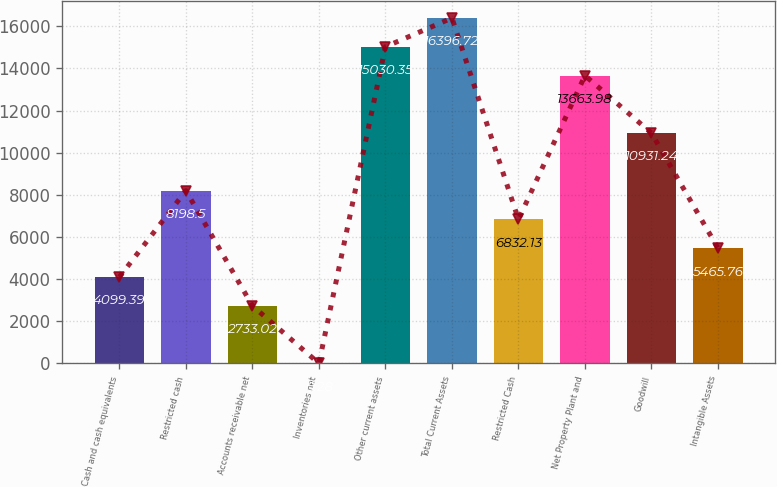Convert chart to OTSL. <chart><loc_0><loc_0><loc_500><loc_500><bar_chart><fcel>Cash and cash equivalents<fcel>Restricted cash<fcel>Accounts receivable net<fcel>Inventories net<fcel>Other current assets<fcel>Total Current Assets<fcel>Restricted Cash<fcel>Net Property Plant and<fcel>Goodwill<fcel>Intangible Assets<nl><fcel>4099.39<fcel>8198.5<fcel>2733.02<fcel>0.28<fcel>15030.4<fcel>16396.7<fcel>6832.13<fcel>13664<fcel>10931.2<fcel>5465.76<nl></chart> 